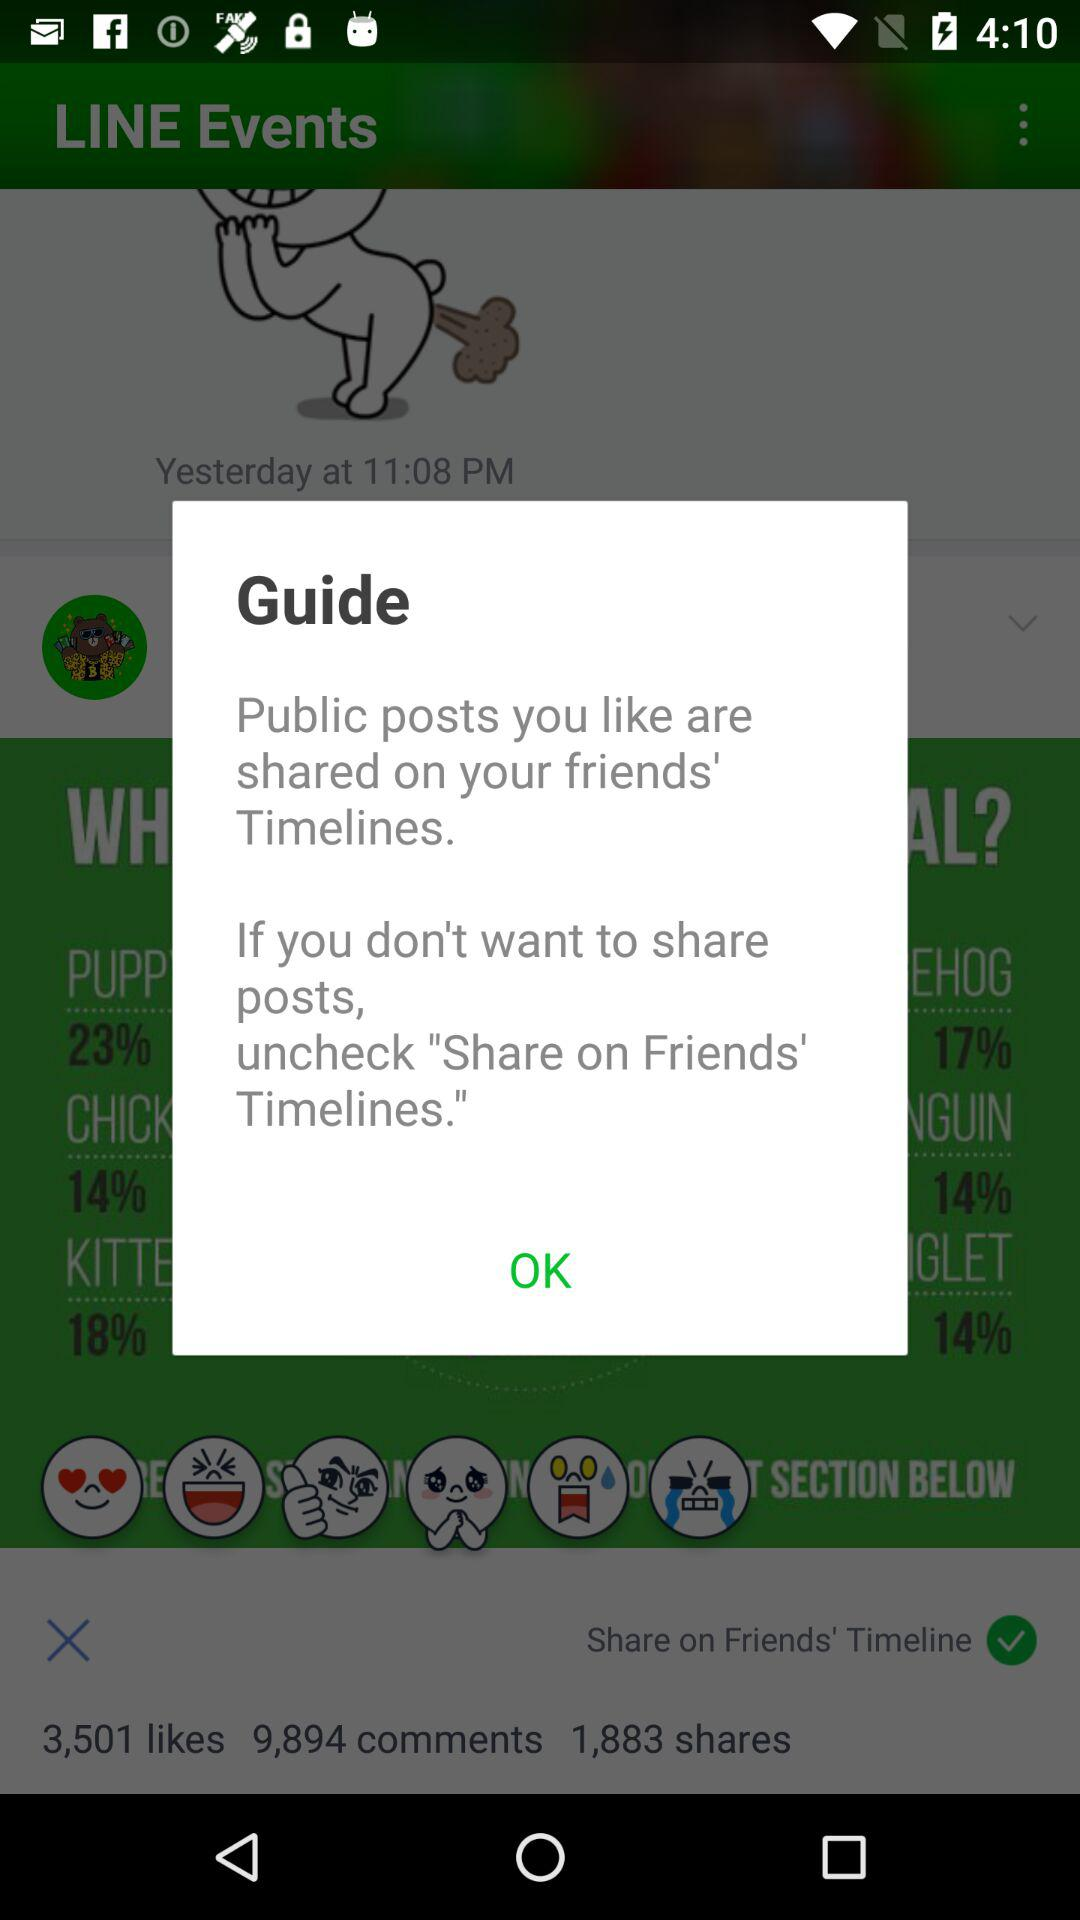How many shares are there? There are 1,883 shares. 